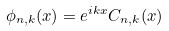<formula> <loc_0><loc_0><loc_500><loc_500>\phi _ { n , k } ( x ) = e ^ { i k x } C _ { n , k } ( x )</formula> 